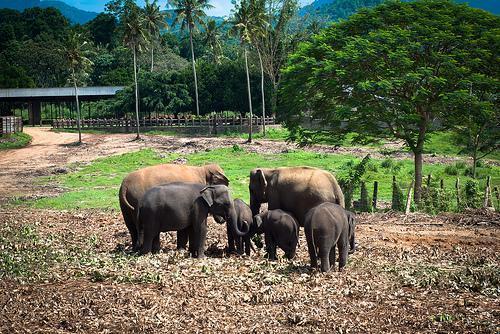How many elephants are there?
Give a very brief answer. 6. 